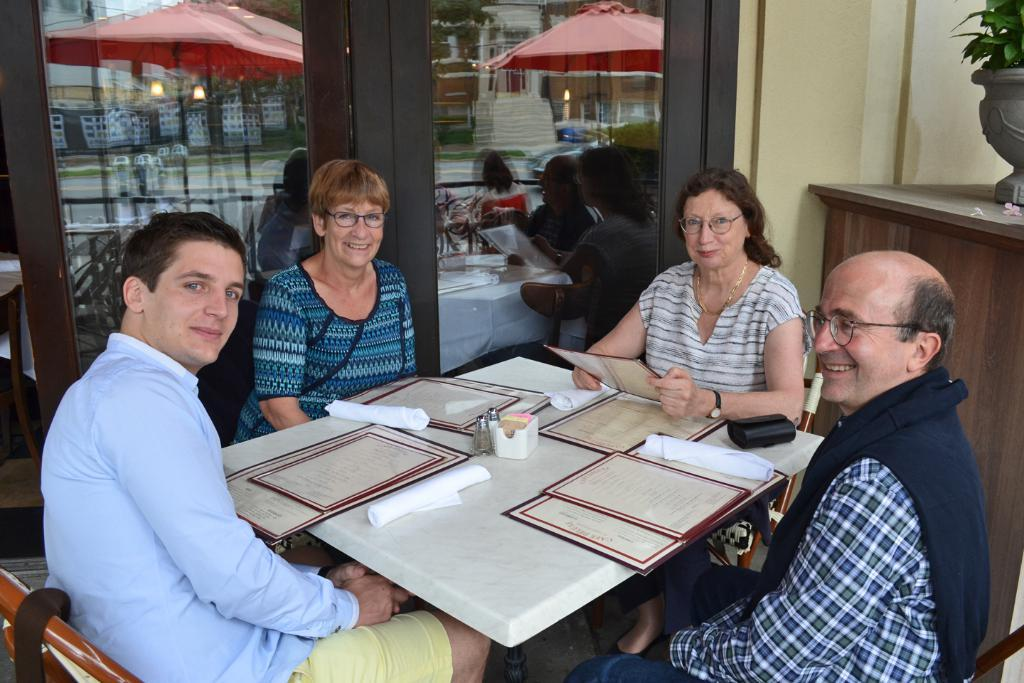How many people are present in the image? There are four people in the image. What are the people doing in the image? The people are sitting in chairs. What is in front of the people? There is a table in front of the people. What can be seen on the table? The table has certificates on it. What shape are the spiders crawling on the table in the image? There are no spiders present in the image, so it is not possible to determine their shape or location. 